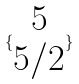Convert formula to latex. <formula><loc_0><loc_0><loc_500><loc_500>\{ \begin{matrix} 5 \\ 5 / 2 \end{matrix} \}</formula> 